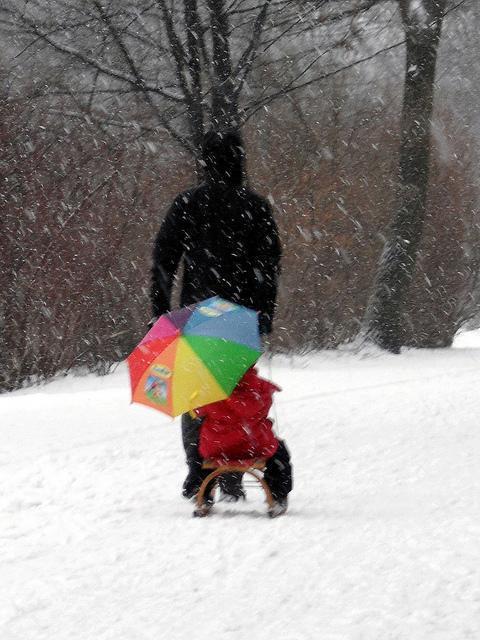How many colors are on the umbrella?
Give a very brief answer. 8. How many people are there?
Give a very brief answer. 2. 